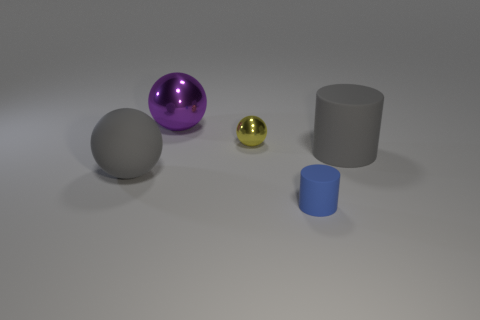There is a shiny thing that is behind the tiny thing behind the tiny object right of the yellow sphere; what is its color?
Offer a terse response. Purple. There is a gray object that is the same shape as the yellow metallic object; what is its material?
Give a very brief answer. Rubber. How many blue cylinders are the same size as the blue matte thing?
Keep it short and to the point. 0. What number of small blue things are there?
Give a very brief answer. 1. Does the small cylinder have the same material as the small object behind the blue cylinder?
Your response must be concise. No. How many yellow objects are tiny metallic cylinders or small shiny things?
Provide a succinct answer. 1. The yellow sphere that is the same material as the big purple object is what size?
Make the answer very short. Small. How many other yellow things are the same shape as the yellow shiny thing?
Give a very brief answer. 0. Are there more big gray rubber spheres behind the large metallic sphere than blue rubber cylinders that are left of the yellow ball?
Ensure brevity in your answer.  No. Do the big metallic thing and the small object right of the yellow thing have the same color?
Offer a terse response. No. 